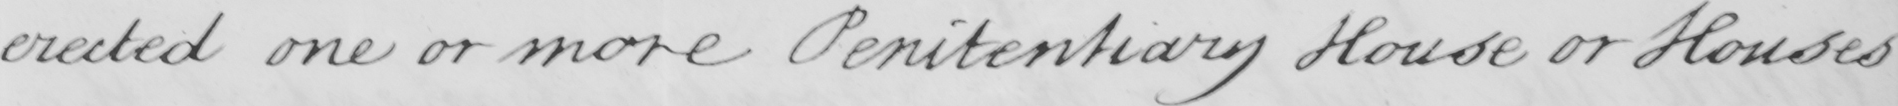Please transcribe the handwritten text in this image. erected one or more Penitentiary House or Houses 